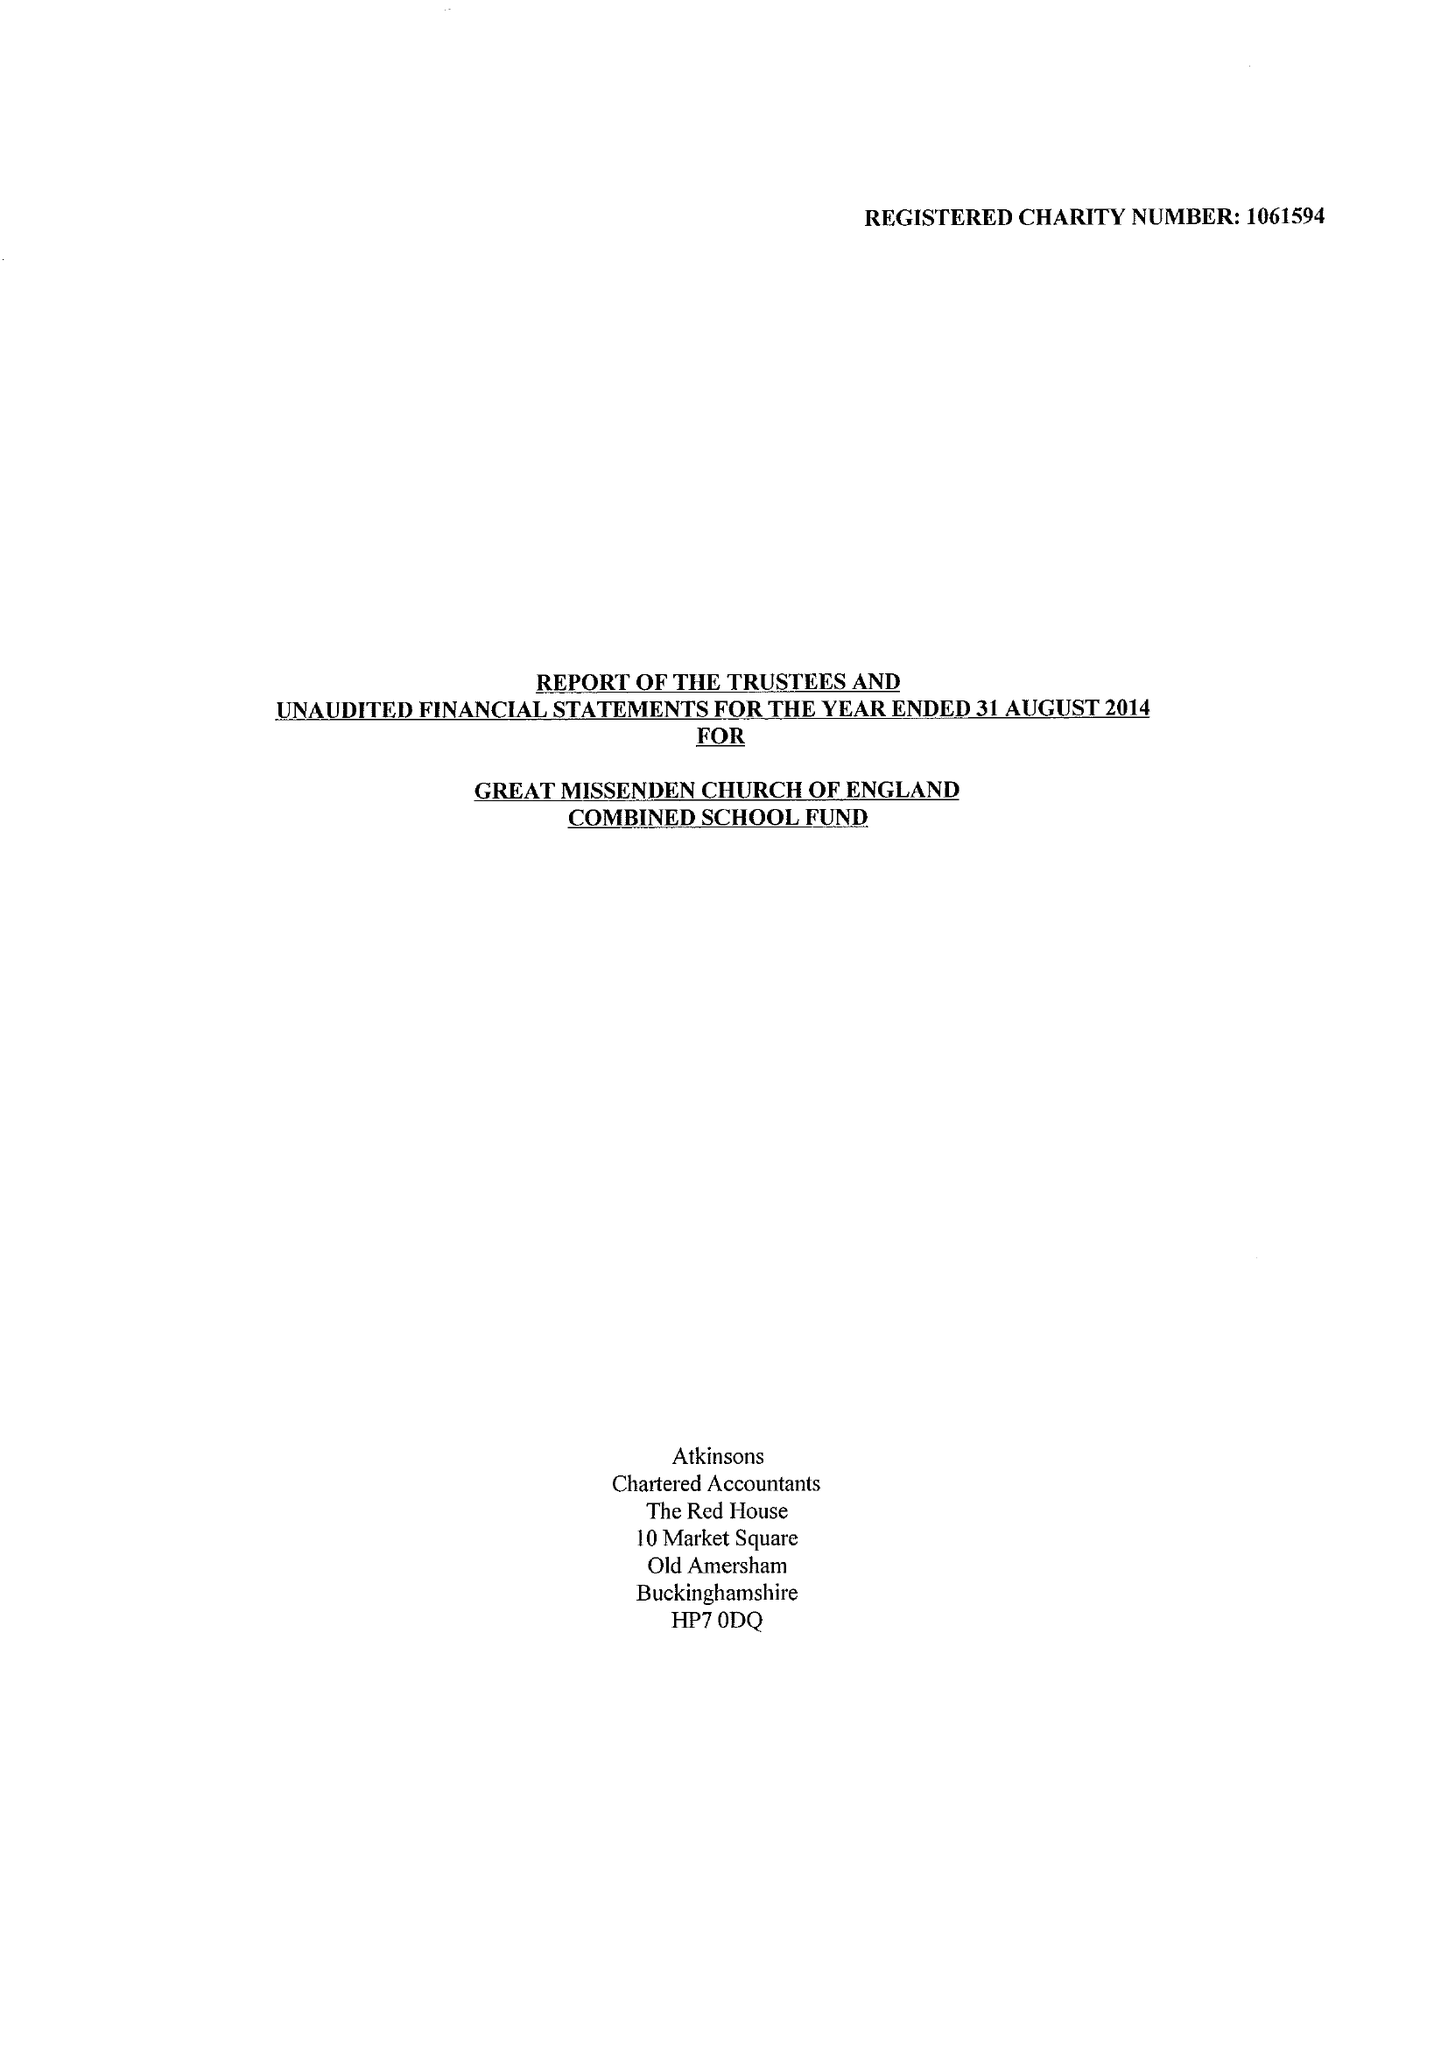What is the value for the report_date?
Answer the question using a single word or phrase. 2014-08-31 